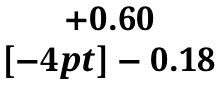<formula> <loc_0><loc_0><loc_500><loc_500>\begin{matrix} + 0 . 6 0 \\ [ - 4 p t ] - 0 . 1 8 \end{matrix}</formula> 